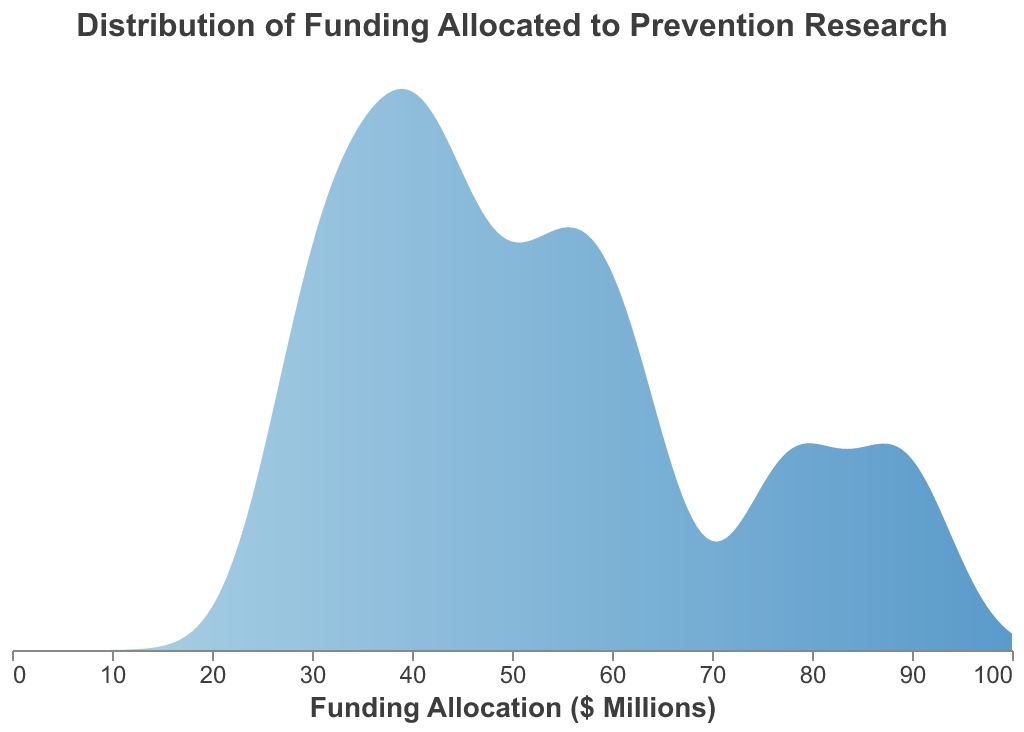What is the title of the figure? The title is usually placed at the top and it describes the subject of the plot. Here, the title is "Distribution of Funding Allocated to Prevention Research."
Answer: Distribution of Funding Allocated to Prevention Research What is the highest funding allocation amount shown on the x-axis? Look at the x-axis values and find the maximum figure. The highest value on the axis is 100 million dollars.
Answer: 100 Which health sector received the lowest funding allocation? The vertical axis displays different health sectors, and their funding is indicated horizontally. The lowest value appears to be associated with "Injury Prevention" which is 29 million dollars.
Answer: Injury Prevention Which two health sectors have funding allocations of more than 75 million dollars? Check the data points that are to the right of 75 million dollars on the x-axis. "Cancer Research" with 78 million dollars, and "Infectious Diseases" with 89 million dollars fit this criterion.
Answer: Cancer Research and Infectious Diseases What is the rough bandwidth used for the density calculation? The bandwidth parameter for density smoothing is typically constant across the plot and is mentioned in the code as 5 million dollars.
Answer: 5 What colors represent the density gradient in the plot? Look at the color gradient that fills the density plot. The gradient moves from a lighter blue shade (starting color) to a darker blue shade (ending color).
Answer: Light blue to dark blue Which sector is closest to the median funding allocation? Calculate the median funding value by arranging the numerical values in order and finding the middle value. The median is the 5th data point in an ordered list (38, 29, 33, 38, 41, 45, 52, 57, 62, 78, 89), which is "Maternal and Child Health" with 41 million dollars.
Answer: Maternal and Child Health What is the combined funding allocation for Mental Health and Cardiovascular Disease? Add the funding amounts of "Mental Health" (45 million dollars) and "Cardiovascular Disease" (62 million dollars). 45 + 62 = 107 million dollars.
Answer: 107 How does the funding allocation for Obesity and Nutrition compare to Substance Abuse? Compare the two amounts on the horizontal axis. "Obesity and Nutrition" received 38 million dollars, while "Substance Abuse" received 52 million dollars. Substance Abuse received more, by 14 million dollars.
Answer: Substance Abuse has 14 million more Is the overall funding distribution skewed towards higher or lower funding allocations? Check the density curve and where most of its area lies. The longer, flatter tail towards higher values suggests a distribution slightly skewed to the right (higher funding amounts).
Answer: Higher funding allocations Which health sector has the closest funding allocation to the mean value? Calculate the mean funding allocation by summing the values and dividing by the number of sectors: (45+78+62+89+52+41+38+33+29+57) / 10 = 52.4 million dollars. "Substance Abuse" with 52 million dollars is closest.
Answer: Substance Abuse 